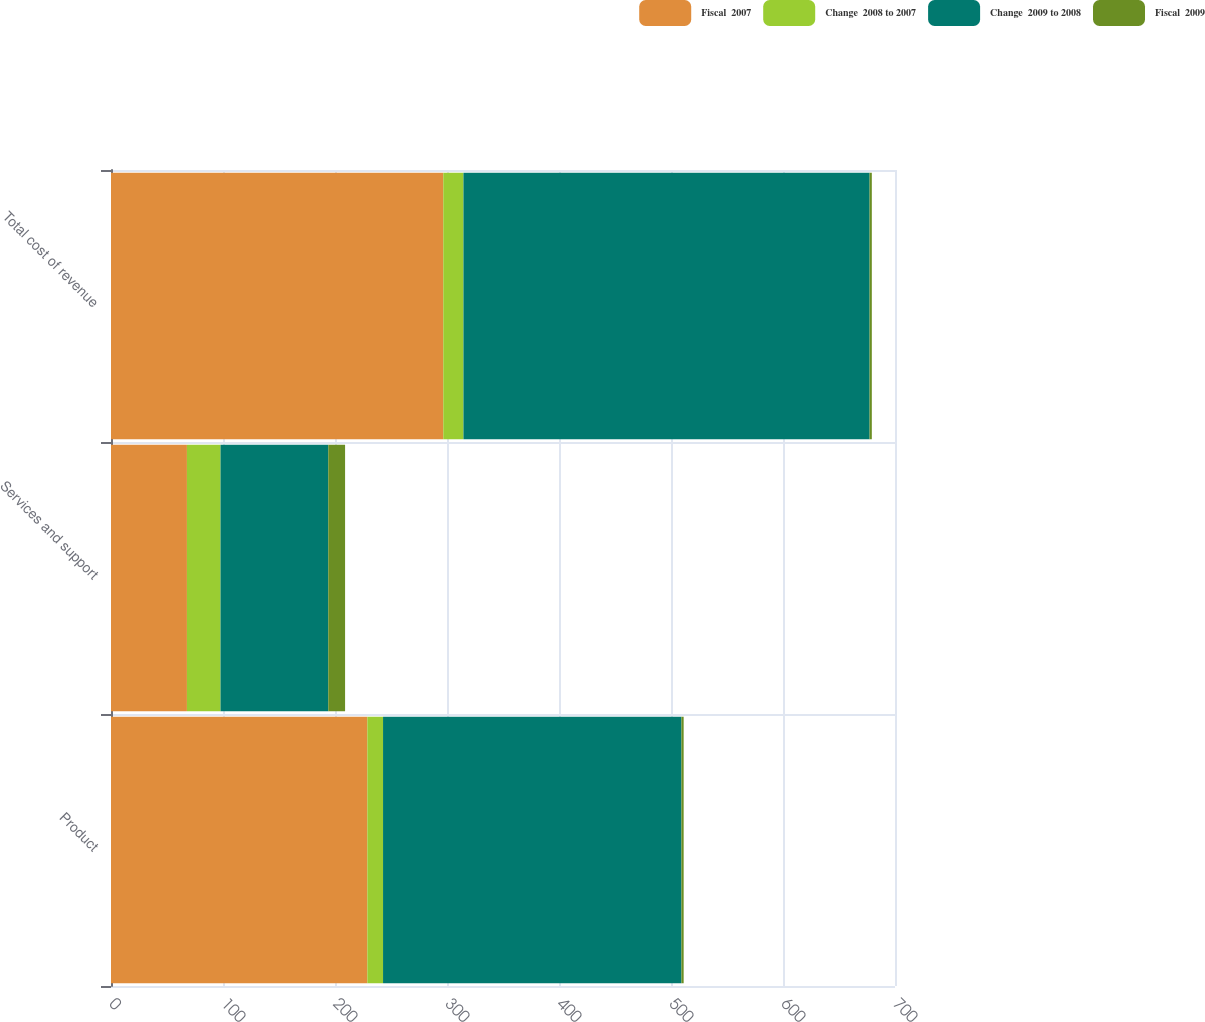Convert chart to OTSL. <chart><loc_0><loc_0><loc_500><loc_500><stacked_bar_chart><ecel><fcel>Product<fcel>Services and support<fcel>Total cost of revenue<nl><fcel>Fiscal  2007<fcel>228.9<fcel>67.8<fcel>296.7<nl><fcel>Change  2008 to 2007<fcel>14<fcel>30<fcel>18<nl><fcel>Change  2009 to 2008<fcel>266.4<fcel>96.2<fcel>362.6<nl><fcel>Fiscal  2009<fcel>2<fcel>15<fcel>2<nl></chart> 